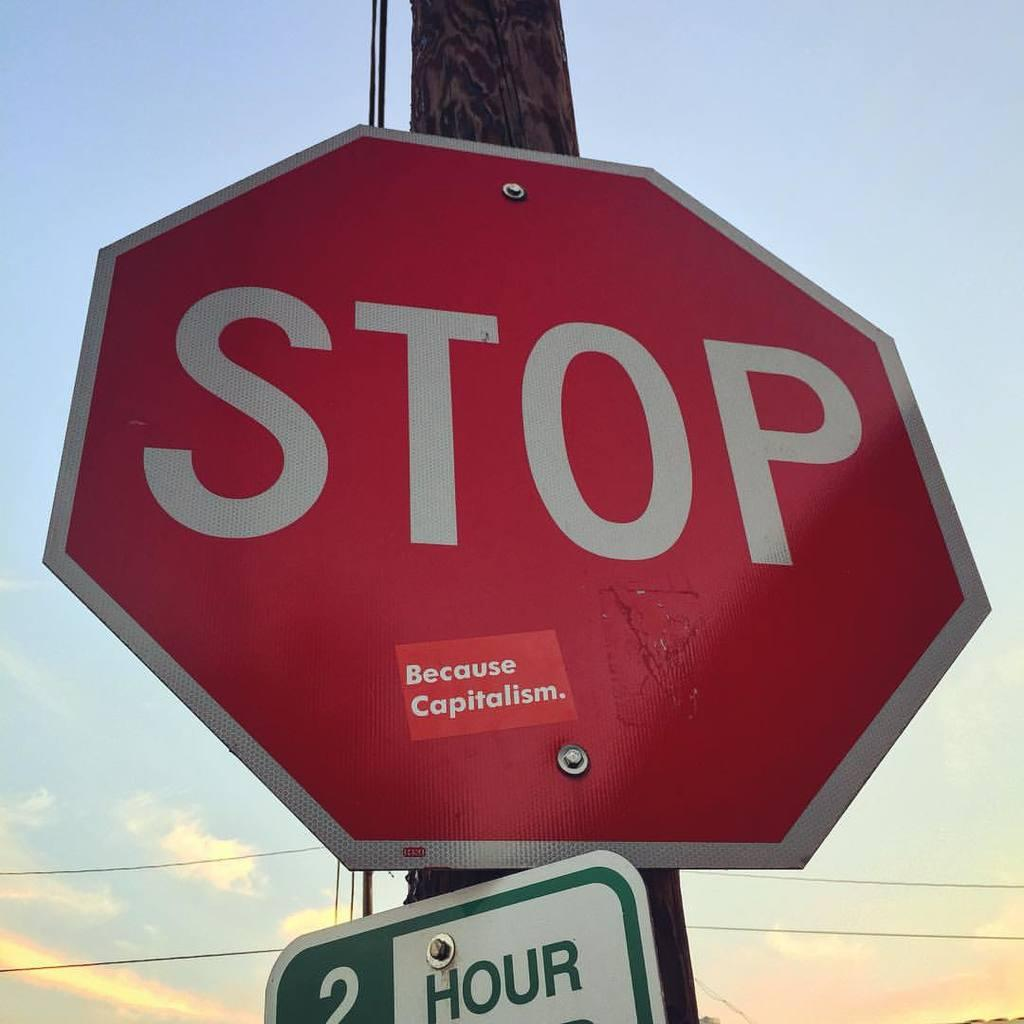What is the main object in the image? There is a pole in the image. What is attached to the pole? There is a stop board and another board attached to the pole. What can be seen in the backdrop of the image? Wires are visible in the backdrop of the image. How would you describe the sky in the image? The sky is clear in the image. What type of doctor is standing near the pole in the image? There is no doctor present in the image; it only features a pole with attached boards and wires in the backdrop. What statement can be made about the mist in the image? There is no mention of mist in the image; the sky is described as clear. 